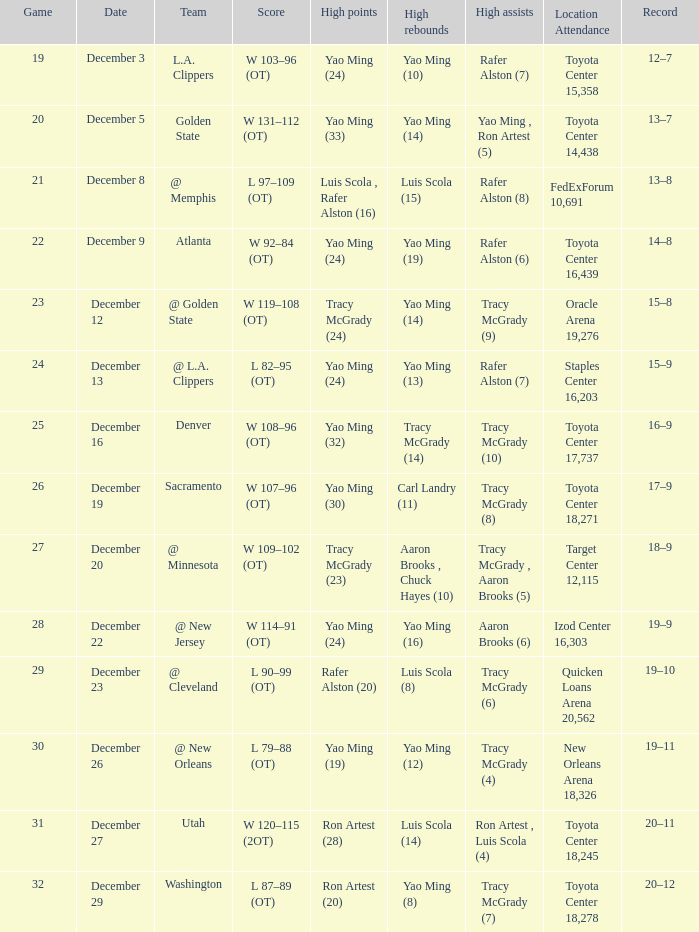When aaron brooks (6) had the highest amount of assists what is the date? December 22. 